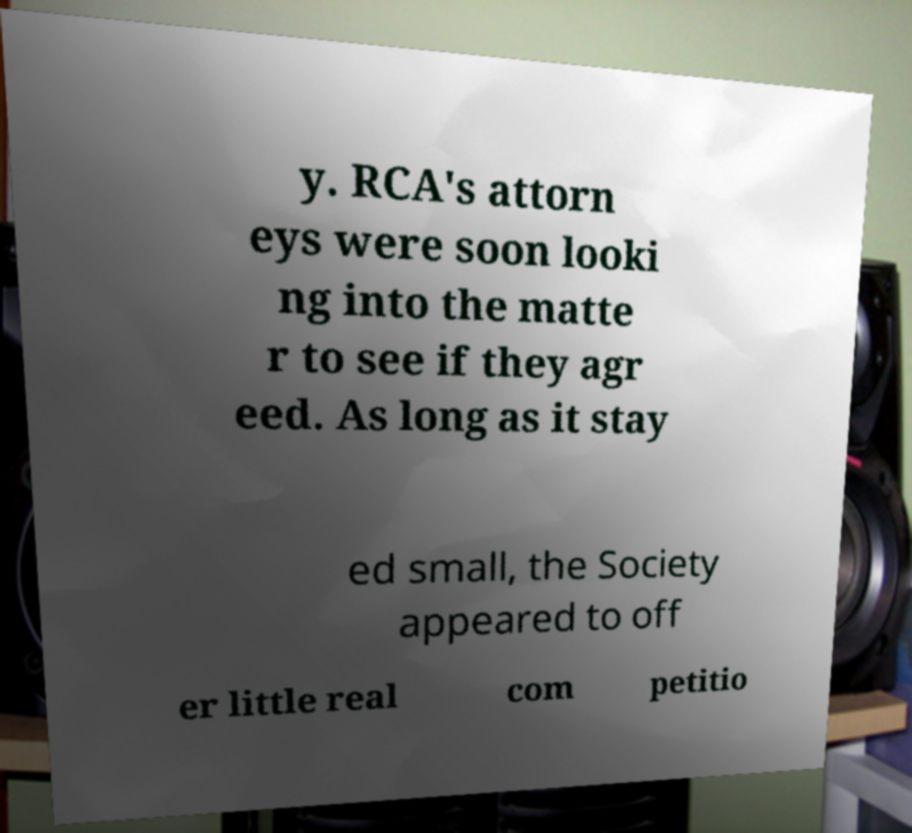Please identify and transcribe the text found in this image. y. RCA's attorn eys were soon looki ng into the matte r to see if they agr eed. As long as it stay ed small, the Society appeared to off er little real com petitio 